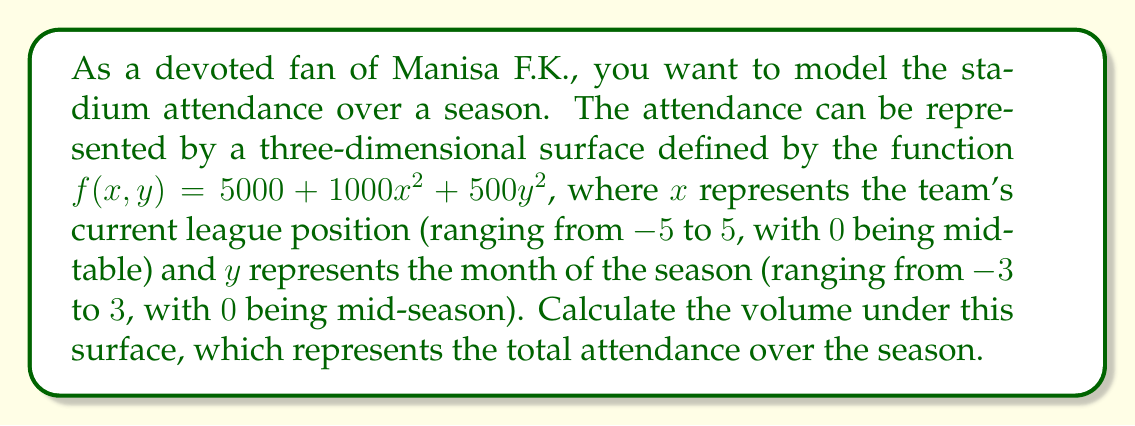Can you solve this math problem? To find the volume under the three-dimensional surface, we need to calculate a triple integral. The steps are as follows:

1) The volume is given by the integral:

   $$V = \int_{-5}^{5} \int_{-3}^{3} \int_{0}^{f(x,y)} dz dy dx$$

2) Substitute the function $f(x,y) = 5000 + 1000x^2 + 500y^2$:

   $$V = \int_{-5}^{5} \int_{-3}^{3} \int_{0}^{5000 + 1000x^2 + 500y^2} dz dy dx$$

3) Integrate with respect to z:

   $$V = \int_{-5}^{5} \int_{-3}^{3} (5000 + 1000x^2 + 500y^2) dy dx$$

4) Integrate with respect to y:

   $$V = \int_{-5}^{5} \left[5000y + 1000x^2y + \frac{500}{3}y^3\right]_{-3}^{3} dx$$
   
   $$V = \int_{-5}^{5} (30000 + 6000x^2 + 4500) dx$$
   
   $$V = \int_{-5}^{5} (34500 + 6000x^2) dx$$

5) Integrate with respect to x:

   $$V = \left[34500x + 2000x^3\right]_{-5}^{5}$$

6) Evaluate the limits:

   $$V = (172500 + 250000) - (-172500 + 250000)$$
   
   $$V = 422500 - 77500 = 345000$$

Therefore, the total attendance over the season is 345,000.
Answer: 345,000 